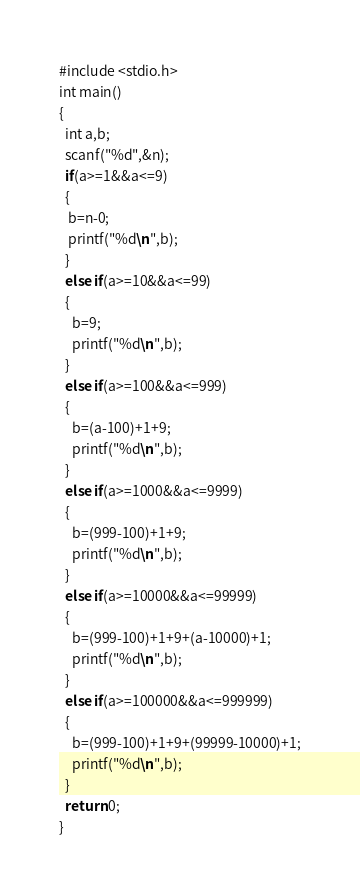Convert code to text. <code><loc_0><loc_0><loc_500><loc_500><_C_>#include <stdio.h>
int main()
{
  int a,b;
  scanf("%d",&n);
  if(a>=1&&a<=9)
  {
   b=n-0;
   printf("%d\n",b);
  }
  else if(a>=10&&a<=99)
  {
    b=9;
    printf("%d\n",b);
  }
  else if(a>=100&&a<=999)
  {
    b=(a-100)+1+9;
    printf("%d\n",b);
  }
  else if(a>=1000&&a<=9999)
  {
    b=(999-100)+1+9;
    printf("%d\n",b);
  }
  else if(a>=10000&&a<=99999)
  {
    b=(999-100)+1+9+(a-10000)+1;
    printf("%d\n",b);
  }
  else if(a>=100000&&a<=999999)
  {
    b=(999-100)+1+9+(99999-10000)+1;
    printf("%d\n",b);
  }
  return 0;
}</code> 